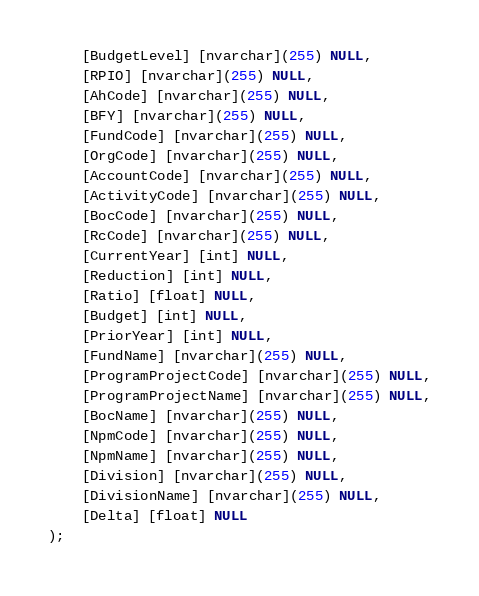Convert code to text. <code><loc_0><loc_0><loc_500><loc_500><_SQL_>	[BudgetLevel] [nvarchar](255) NULL,
	[RPIO] [nvarchar](255) NULL,
	[AhCode] [nvarchar](255) NULL,
	[BFY] [nvarchar](255) NULL,
	[FundCode] [nvarchar](255) NULL,
	[OrgCode] [nvarchar](255) NULL,
	[AccountCode] [nvarchar](255) NULL,
	[ActivityCode] [nvarchar](255) NULL,
	[BocCode] [nvarchar](255) NULL,
	[RcCode] [nvarchar](255) NULL,
	[CurrentYear] [int] NULL,
	[Reduction] [int] NULL,
	[Ratio] [float] NULL,
	[Budget] [int] NULL,
	[PriorYear] [int] NULL,
	[FundName] [nvarchar](255) NULL,
	[ProgramProjectCode] [nvarchar](255) NULL,
	[ProgramProjectName] [nvarchar](255) NULL,
	[BocName] [nvarchar](255) NULL,
	[NpmCode] [nvarchar](255) NULL,
	[NpmName] [nvarchar](255) NULL,
	[Division] [nvarchar](255) NULL,
	[DivisionName] [nvarchar](255) NULL,
	[Delta] [float] NULL
);

</code> 